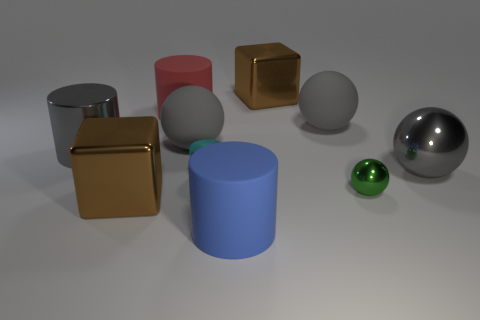Subtract all green cylinders. How many gray balls are left? 3 Subtract all cylinders. How many objects are left? 6 Subtract all small metallic spheres. Subtract all large brown things. How many objects are left? 7 Add 3 big metallic objects. How many big metallic objects are left? 7 Add 10 tiny gray shiny cylinders. How many tiny gray shiny cylinders exist? 10 Subtract 0 gray cubes. How many objects are left? 10 